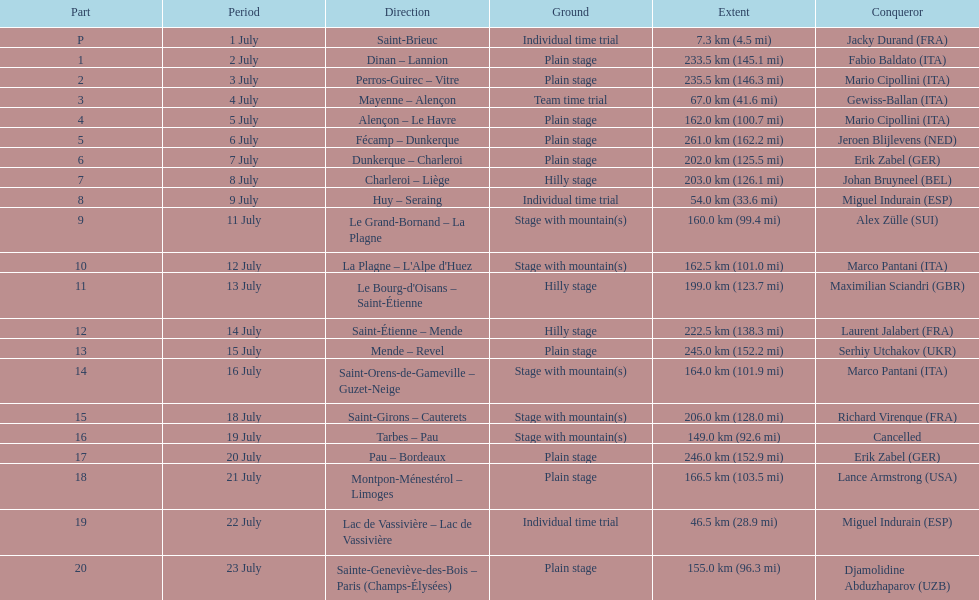How many uninterrupted km were run on july 8th? 203.0 km (126.1 mi). 